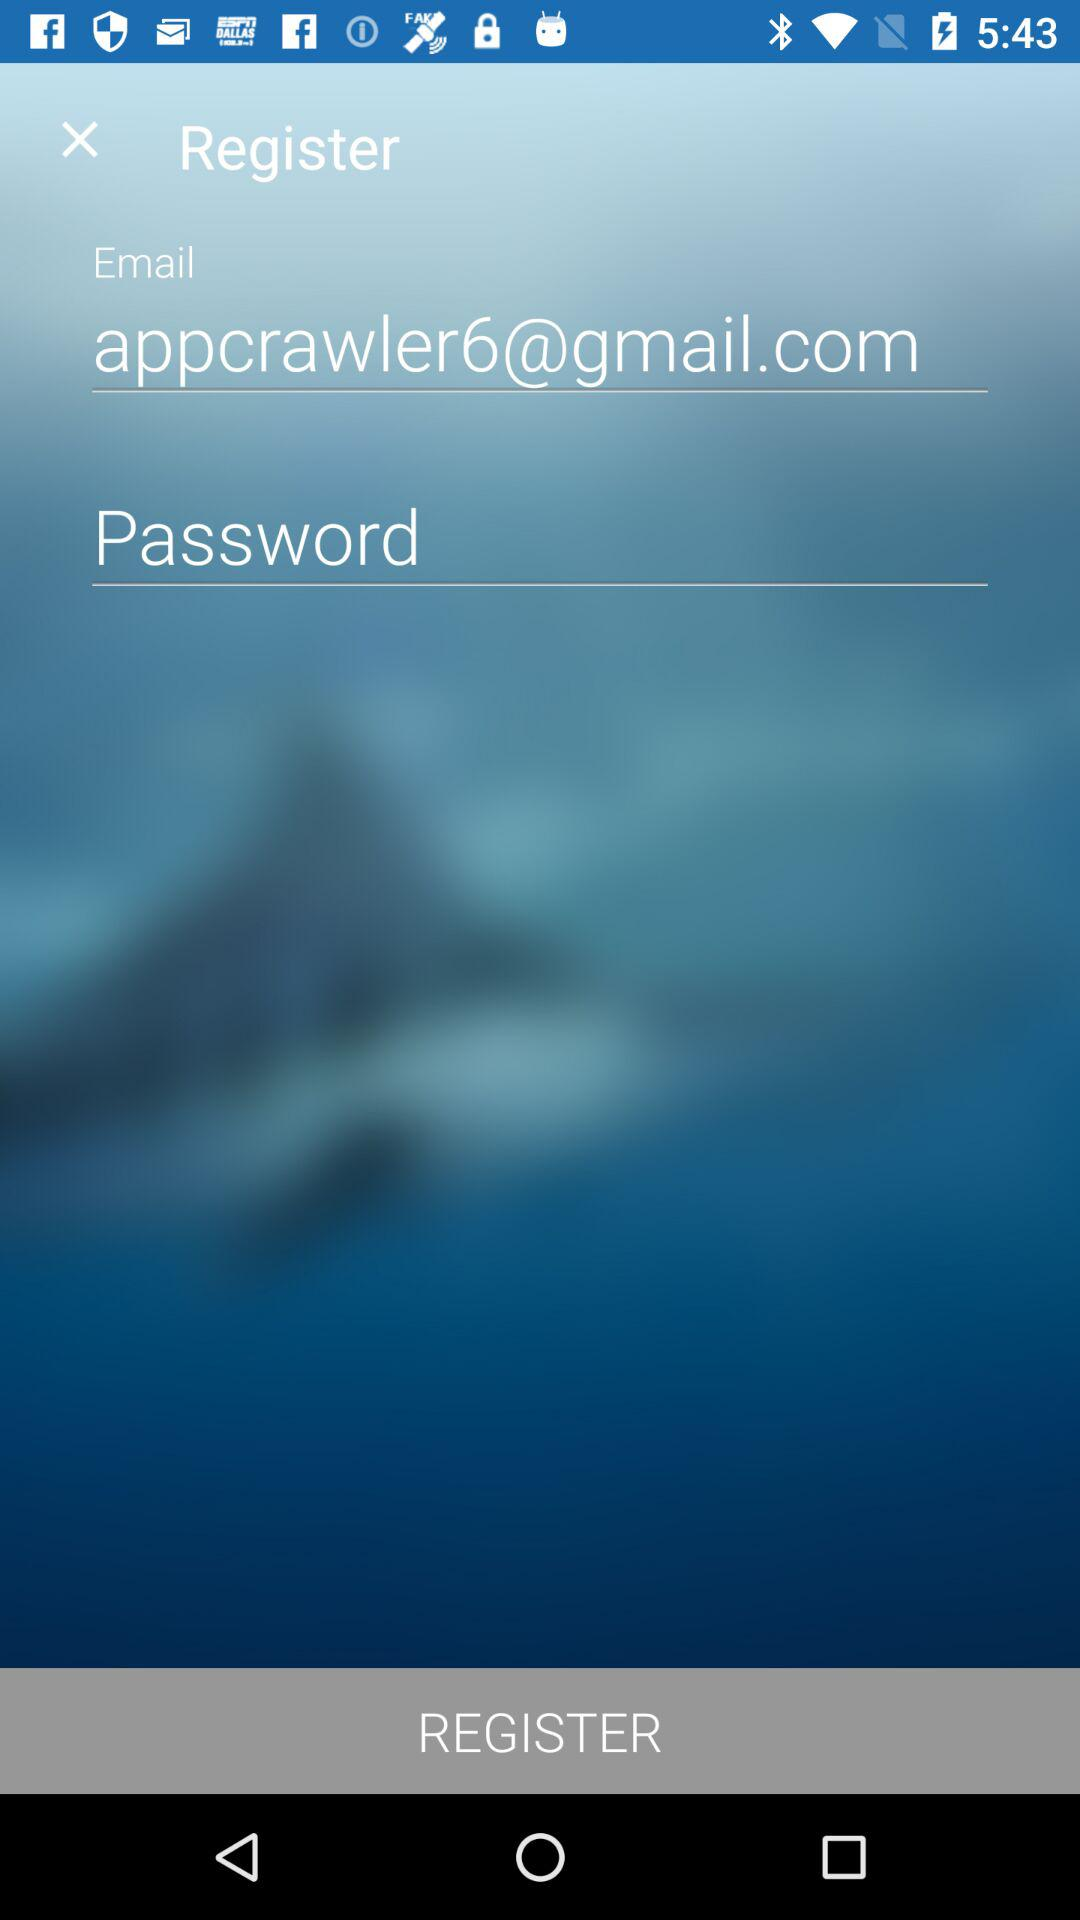How many text input fields are there on this page?
Answer the question using a single word or phrase. 2 